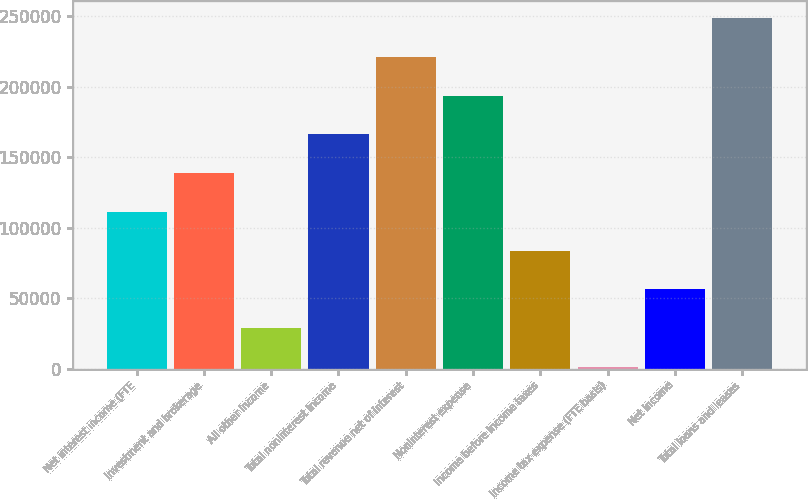<chart> <loc_0><loc_0><loc_500><loc_500><bar_chart><fcel>Net interest income (FTE<fcel>Investment and brokerage<fcel>All other income<fcel>Total noninterest income<fcel>Total revenue net of interest<fcel>Noninterest expense<fcel>Income before income taxes<fcel>Income tax expense (FTE basis)<fcel>Net income<fcel>Total loans and leases<nl><fcel>111245<fcel>138682<fcel>28934.8<fcel>166119<fcel>220992<fcel>193556<fcel>83808.4<fcel>1498<fcel>56371.6<fcel>248429<nl></chart> 